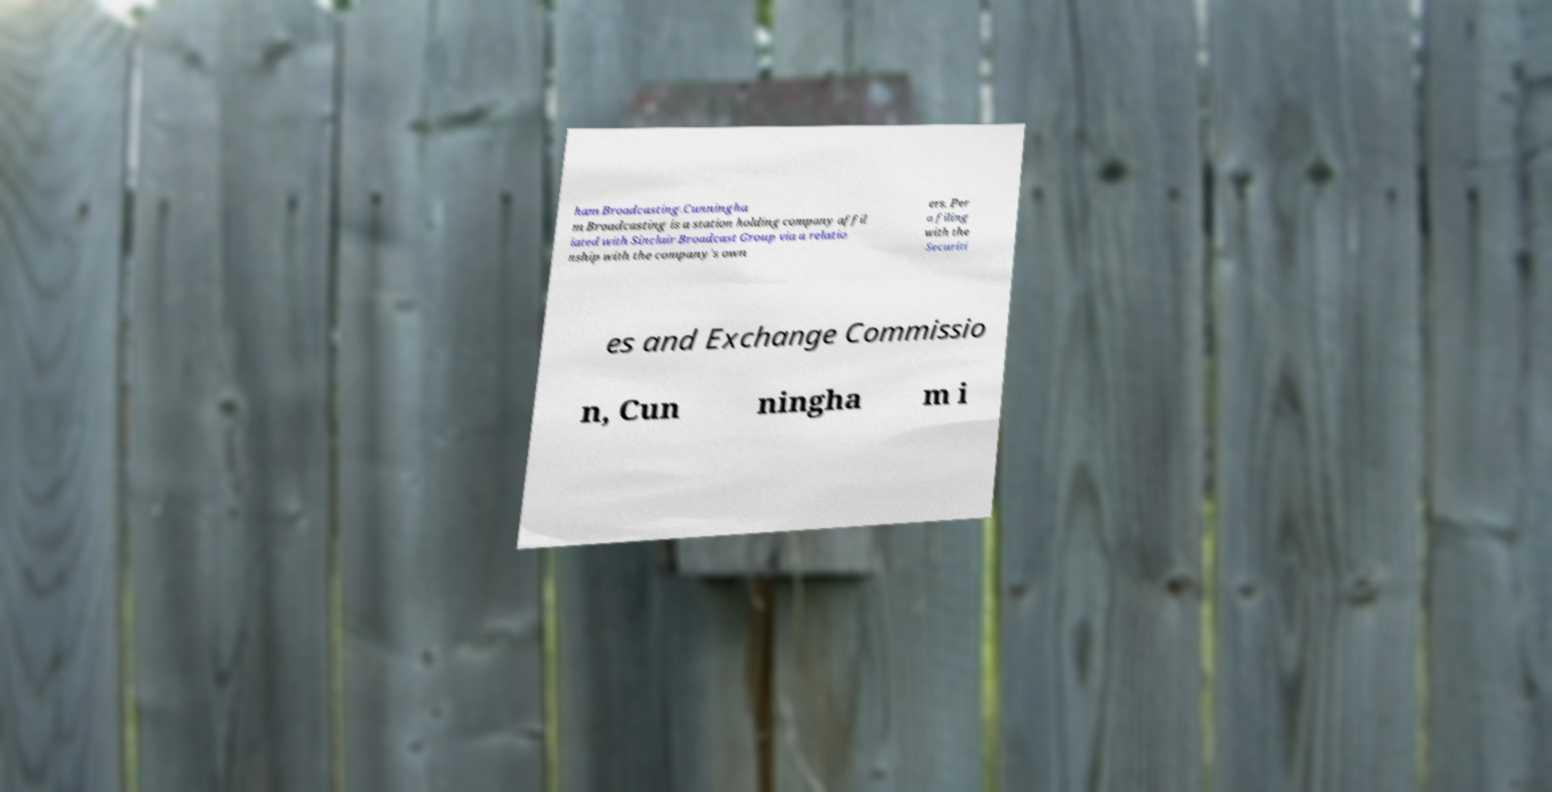Could you assist in decoding the text presented in this image and type it out clearly? ham Broadcasting.Cunningha m Broadcasting is a station holding company affil iated with Sinclair Broadcast Group via a relatio nship with the company's own ers. Per a filing with the Securiti es and Exchange Commissio n, Cun ningha m i 